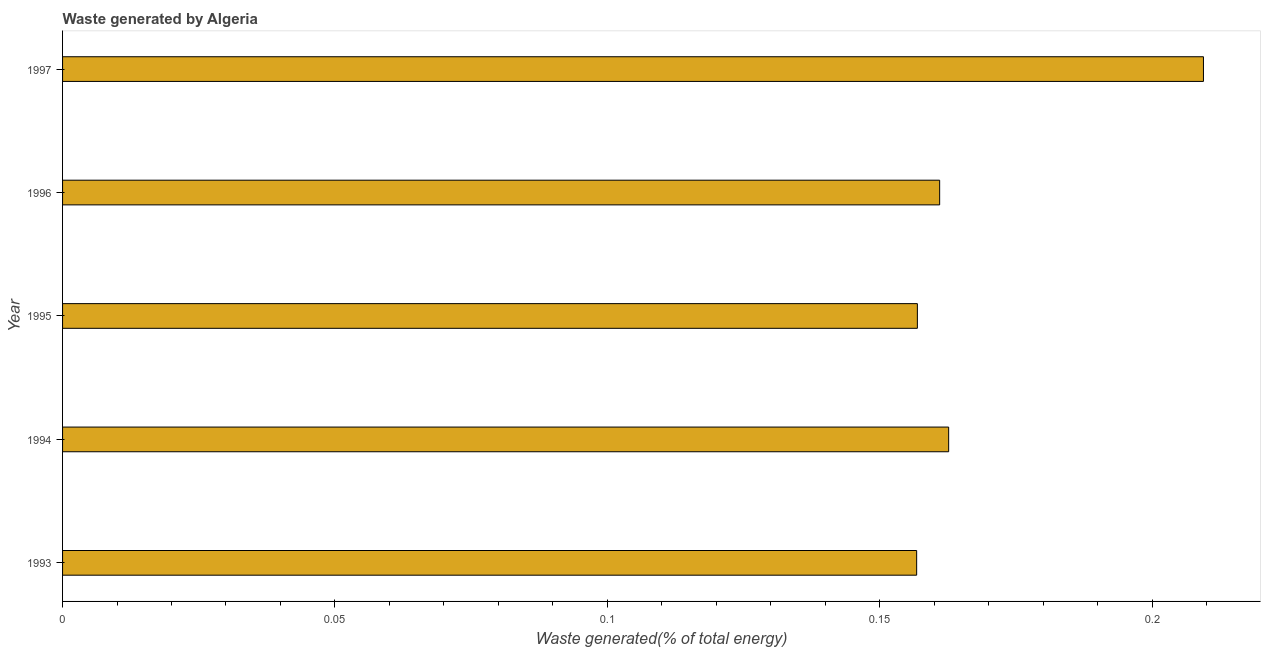Does the graph contain grids?
Offer a very short reply. No. What is the title of the graph?
Make the answer very short. Waste generated by Algeria. What is the label or title of the X-axis?
Offer a very short reply. Waste generated(% of total energy). What is the amount of waste generated in 1996?
Your answer should be compact. 0.16. Across all years, what is the maximum amount of waste generated?
Offer a terse response. 0.21. Across all years, what is the minimum amount of waste generated?
Offer a terse response. 0.16. In which year was the amount of waste generated maximum?
Your response must be concise. 1997. In which year was the amount of waste generated minimum?
Ensure brevity in your answer.  1993. What is the sum of the amount of waste generated?
Provide a short and direct response. 0.85. What is the difference between the amount of waste generated in 1993 and 1995?
Provide a short and direct response. -0. What is the average amount of waste generated per year?
Provide a short and direct response. 0.17. What is the median amount of waste generated?
Make the answer very short. 0.16. In how many years, is the amount of waste generated greater than 0.04 %?
Give a very brief answer. 5. What is the ratio of the amount of waste generated in 1993 to that in 1996?
Offer a very short reply. 0.97. Is the amount of waste generated in 1995 less than that in 1996?
Keep it short and to the point. Yes. Is the difference between the amount of waste generated in 1996 and 1997 greater than the difference between any two years?
Make the answer very short. No. What is the difference between the highest and the second highest amount of waste generated?
Give a very brief answer. 0.05. What is the difference between the highest and the lowest amount of waste generated?
Keep it short and to the point. 0.05. In how many years, is the amount of waste generated greater than the average amount of waste generated taken over all years?
Provide a short and direct response. 1. Are all the bars in the graph horizontal?
Provide a succinct answer. Yes. Are the values on the major ticks of X-axis written in scientific E-notation?
Offer a terse response. No. What is the Waste generated(% of total energy) in 1993?
Keep it short and to the point. 0.16. What is the Waste generated(% of total energy) in 1994?
Give a very brief answer. 0.16. What is the Waste generated(% of total energy) in 1995?
Provide a short and direct response. 0.16. What is the Waste generated(% of total energy) of 1996?
Your response must be concise. 0.16. What is the Waste generated(% of total energy) in 1997?
Make the answer very short. 0.21. What is the difference between the Waste generated(% of total energy) in 1993 and 1994?
Your response must be concise. -0.01. What is the difference between the Waste generated(% of total energy) in 1993 and 1995?
Keep it short and to the point. -0. What is the difference between the Waste generated(% of total energy) in 1993 and 1996?
Offer a very short reply. -0. What is the difference between the Waste generated(% of total energy) in 1993 and 1997?
Your answer should be compact. -0.05. What is the difference between the Waste generated(% of total energy) in 1994 and 1995?
Your answer should be compact. 0.01. What is the difference between the Waste generated(% of total energy) in 1994 and 1996?
Give a very brief answer. 0. What is the difference between the Waste generated(% of total energy) in 1994 and 1997?
Keep it short and to the point. -0.05. What is the difference between the Waste generated(% of total energy) in 1995 and 1996?
Make the answer very short. -0. What is the difference between the Waste generated(% of total energy) in 1995 and 1997?
Make the answer very short. -0.05. What is the difference between the Waste generated(% of total energy) in 1996 and 1997?
Ensure brevity in your answer.  -0.05. What is the ratio of the Waste generated(% of total energy) in 1993 to that in 1996?
Your answer should be very brief. 0.97. What is the ratio of the Waste generated(% of total energy) in 1993 to that in 1997?
Your answer should be very brief. 0.75. What is the ratio of the Waste generated(% of total energy) in 1994 to that in 1997?
Your response must be concise. 0.78. What is the ratio of the Waste generated(% of total energy) in 1995 to that in 1996?
Offer a terse response. 0.97. What is the ratio of the Waste generated(% of total energy) in 1995 to that in 1997?
Provide a succinct answer. 0.75. What is the ratio of the Waste generated(% of total energy) in 1996 to that in 1997?
Offer a terse response. 0.77. 